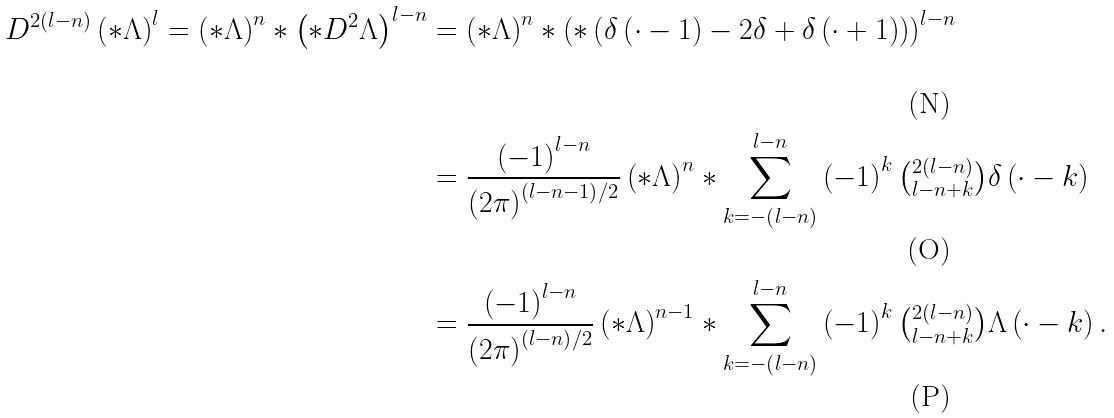Convert formula to latex. <formula><loc_0><loc_0><loc_500><loc_500>D ^ { 2 \left ( l - n \right ) } \left ( \ast \Lambda \right ) ^ { l } = \left ( \ast \Lambda \right ) ^ { n } \ast \left ( \ast D ^ { 2 } \Lambda \right ) ^ { l - n } & = \left ( \ast \Lambda \right ) ^ { n } \ast \left ( \ast \left ( \delta \left ( \cdot - 1 \right ) - 2 \delta + \delta \left ( \cdot + 1 \right ) \right ) \right ) ^ { l - n } \\ & = \frac { \left ( - 1 \right ) ^ { l - n } } { \left ( 2 \pi \right ) ^ { \left ( l - n - 1 \right ) / 2 } } \left ( \ast \Lambda \right ) ^ { n } \ast \sum _ { k = - \left ( l - n \right ) } ^ { l - n } \left ( - 1 \right ) ^ { k } \tbinom { 2 \left ( l - n \right ) } { l - n + k } \delta \left ( \cdot - k \right ) \\ & = \frac { \left ( - 1 \right ) ^ { l - n } } { \left ( 2 \pi \right ) ^ { \left ( l - n \right ) / 2 } } \left ( \ast \Lambda \right ) ^ { n - 1 } \ast \sum _ { k = - \left ( l - n \right ) } ^ { l - n } \left ( - 1 \right ) ^ { k } \tbinom { 2 \left ( l - n \right ) } { l - n + k } \Lambda \left ( \cdot - k \right ) .</formula> 